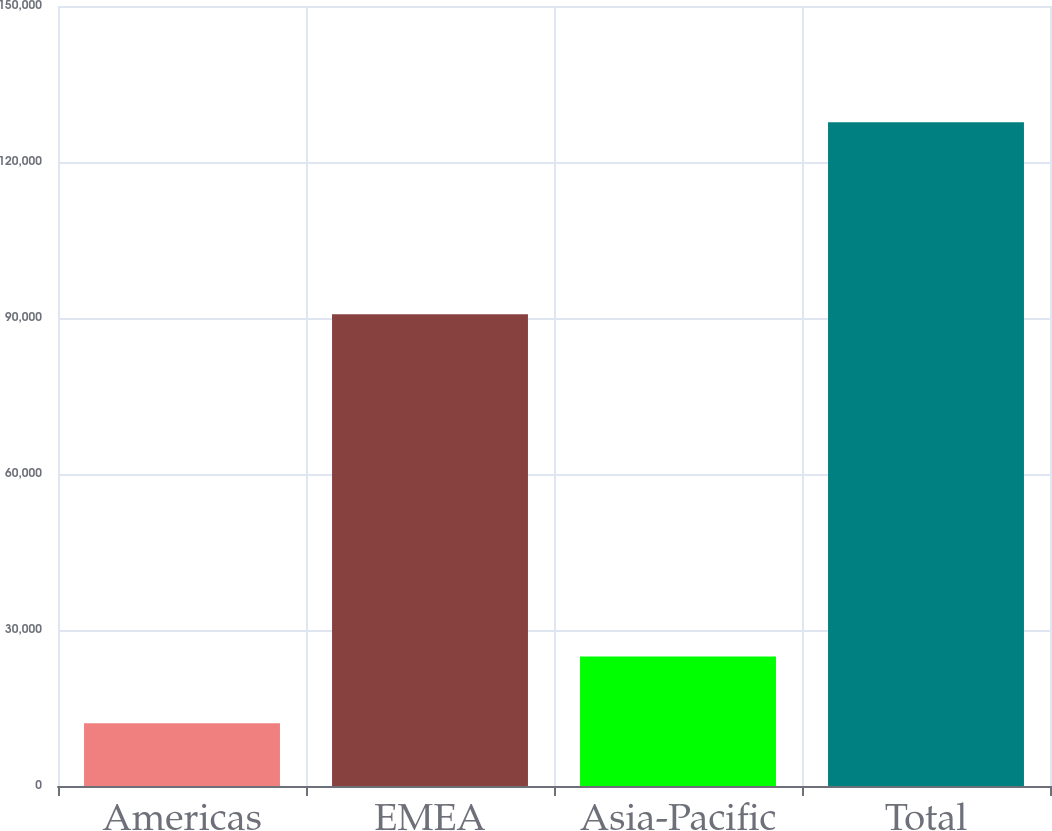Convert chart to OTSL. <chart><loc_0><loc_0><loc_500><loc_500><bar_chart><fcel>Americas<fcel>EMEA<fcel>Asia-Pacific<fcel>Total<nl><fcel>12052<fcel>90717<fcel>24882<fcel>127651<nl></chart> 